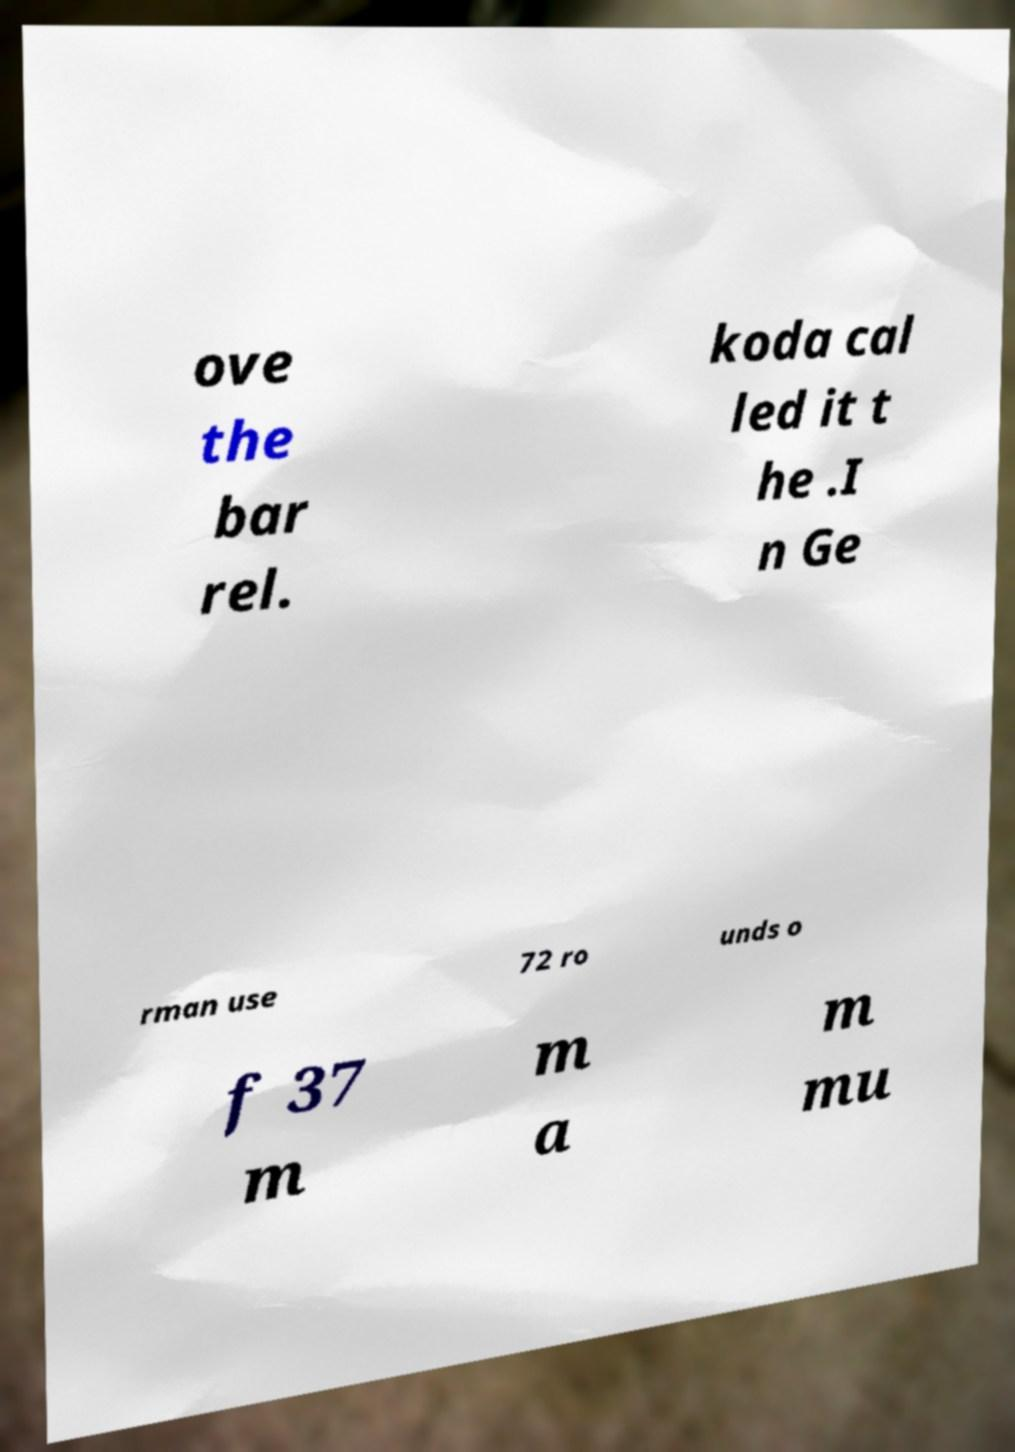Could you extract and type out the text from this image? ove the bar rel. koda cal led it t he .I n Ge rman use 72 ro unds o f 37 m m a m mu 